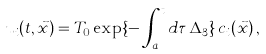<formula> <loc_0><loc_0><loc_500><loc_500>u _ { i } ( t , \vec { x } ) = { T } _ { 0 } \exp \{ - \int _ { a } ^ { t } d \tau \, { \Delta _ { 3 } } \} \, c _ { i } ( \vec { x } ) \, ,</formula> 